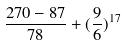<formula> <loc_0><loc_0><loc_500><loc_500>\frac { 2 7 0 - 8 7 } { 7 8 } + ( \frac { 9 } { 6 } ) ^ { 1 7 }</formula> 